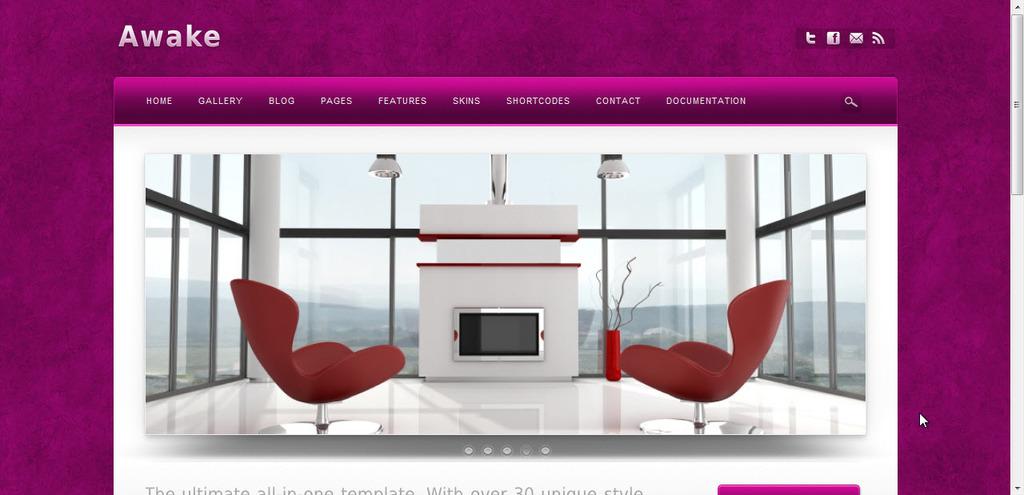What is one of the options at the top of the page?
Keep it short and to the point. Home. 